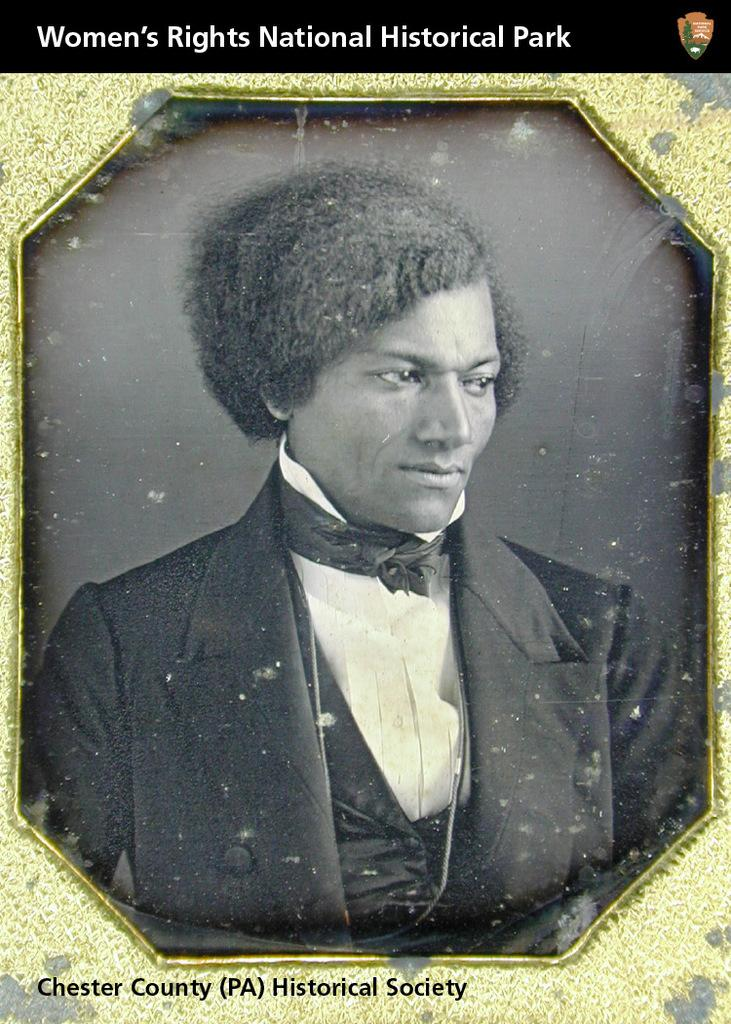<image>
Relay a brief, clear account of the picture shown. A heading for Women's Rights National Historical Park. 